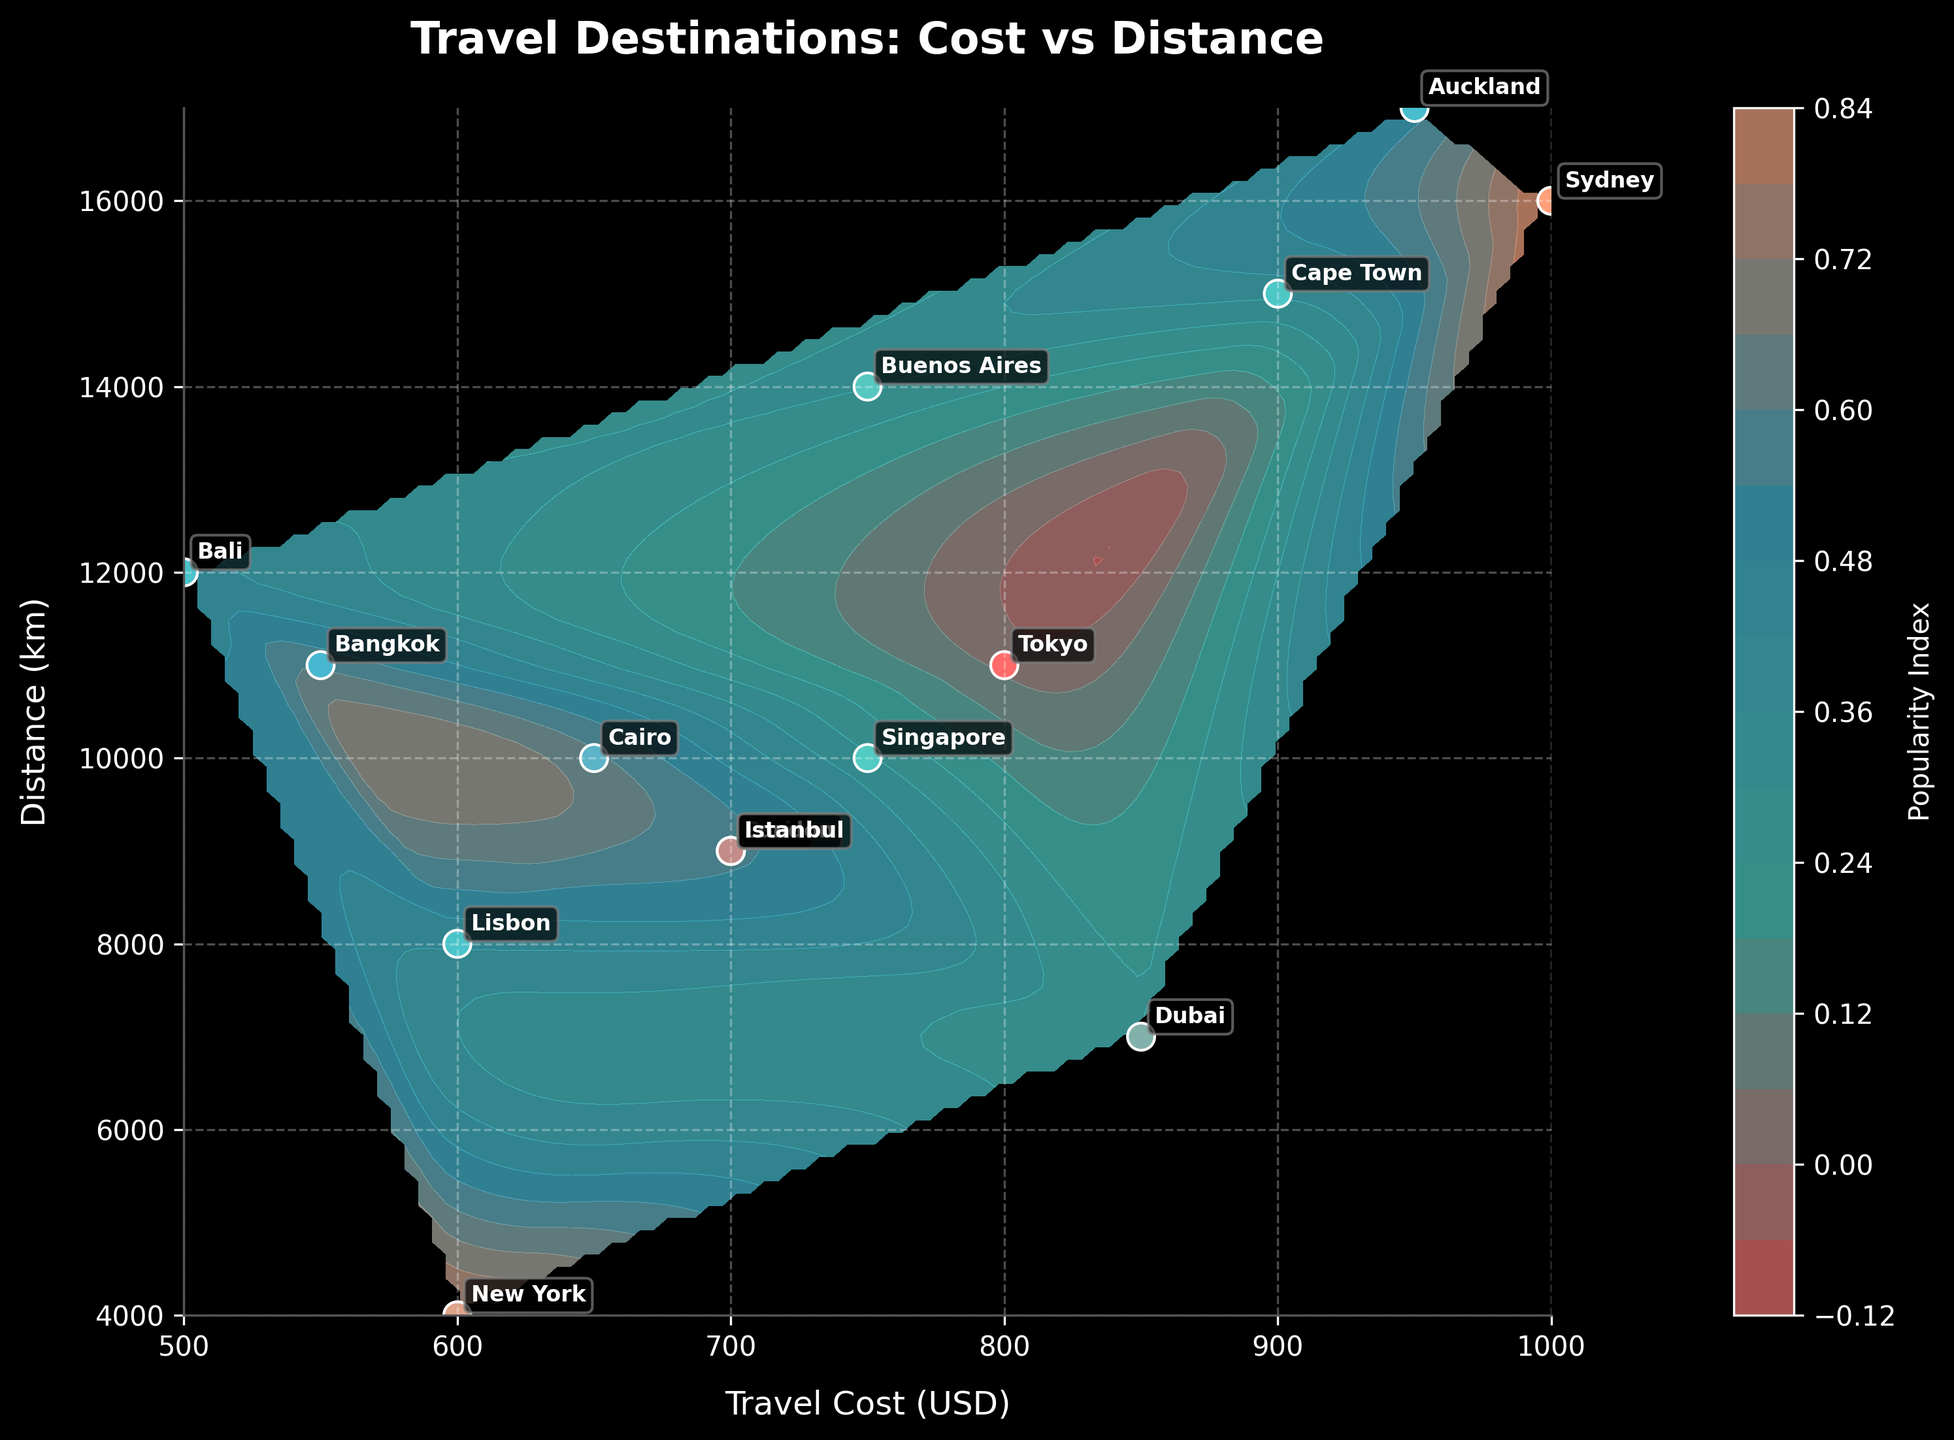what is the title of the plot? The title is displayed prominently at the top of the figure. It says "Travel Destinations: Cost vs Distance."
Answer: Travel Destinations: Cost vs Distance What does the color represent in the contour plot? The color in the contour plot is indicated by the color bar on the right side of the plot. It represents the "Popularity Index."
Answer: Popularity Index Which destination is the furthest distance from the origin? By observing the y-axis, the point with the highest value corresponds to Auckland at 17,000 km.
Answer: Auckland Which destination indicates the lowest travel cost? By examining the x-axis, the destination with the lowest x-value, which is 500 USD, corresponds to Bali.
Answer: Bali How many data points are plotted on the scatter plot? Each labeled point on the scatter plot represents a travel destination. Counting each label shows there are 15 destinations.
Answer: 15 Which destination has higher travel cost but a slightly shorter distance than Tokyo? Tokyo's coordinates are (800, 11000). By comparing nearby points, Sydney (1000, 16000) has a higher travel cost and a greater distance.
Answer: Sydney What is the travel cost and distance of Dubai compared to Istanbul? The scatter plot shows Dubai at coordinates (850, 7000) and Istanbul at (700, 9000). Dubai has a higher travel cost but a shorter distance than Istanbul.
Answer: Dubai has higher cost, shorter distance Which destination pairs are equidistant from the origin? Observing the y-axis indicates that Paris, London, and Istanbul all have the same distance of 9000 km.
Answer: Paris, London, Istanbul Which destination is relatively closer but has a higher travel cost than Bangkok? Bangkok is situated at (550, 11000). Filtering through nearby points, Tokyo at (800, 11000) is closer but with a higher cost.
Answer: Tokyo What does the grid in the background indicate? The grid enhances readability, facilitating the tracking of values on the x and y-axes. It's a dashed line grid for better visualization of position.
Answer: Enhanced readability 